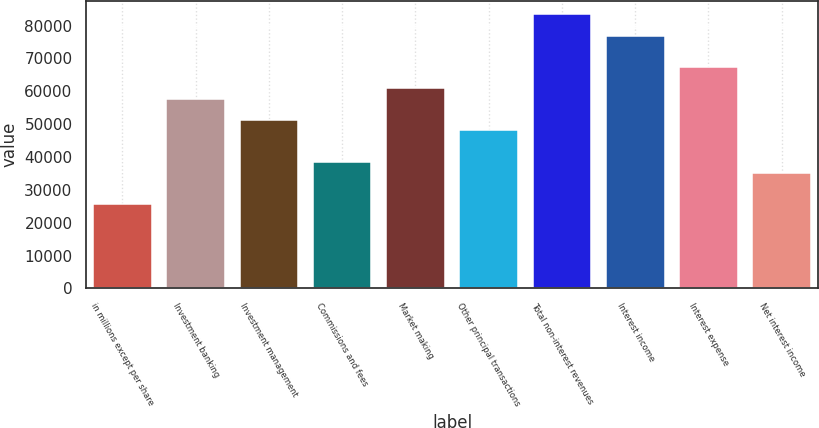Convert chart. <chart><loc_0><loc_0><loc_500><loc_500><bar_chart><fcel>in millions except per share<fcel>Investment banking<fcel>Investment management<fcel>Commissions and fees<fcel>Market making<fcel>Other principal transactions<fcel>Total non-interest revenues<fcel>Interest income<fcel>Interest expense<fcel>Net interest income<nl><fcel>25660.2<fcel>57724.2<fcel>51311.4<fcel>38485.8<fcel>60930.6<fcel>48105<fcel>83375.4<fcel>76962.6<fcel>67343.4<fcel>35279.4<nl></chart> 